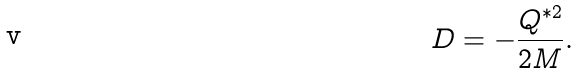Convert formula to latex. <formula><loc_0><loc_0><loc_500><loc_500>D = - \frac { Q ^ { * 2 } } { 2 M } .</formula> 